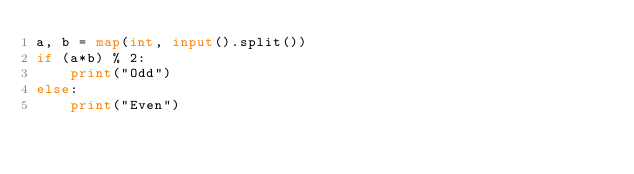Convert code to text. <code><loc_0><loc_0><loc_500><loc_500><_Python_>a, b = map(int, input().split())
if (a*b) % 2:
    print("Odd")
else:
    print("Even")</code> 